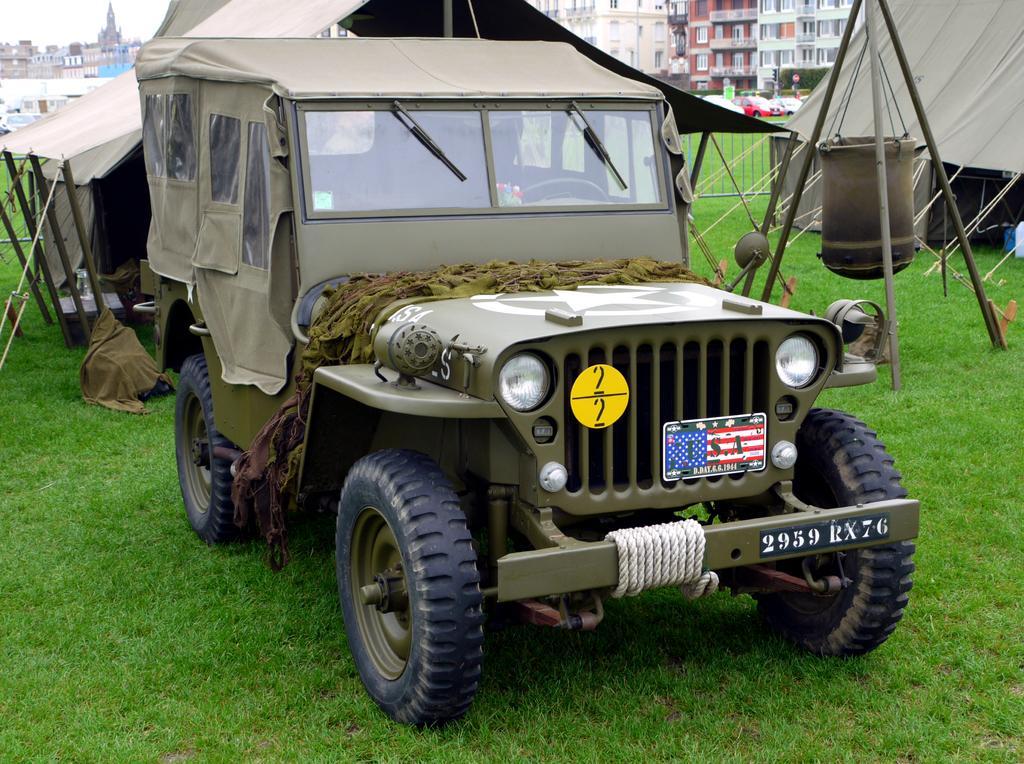Can you describe this image briefly? In this picture we can see a jeep here, at the bottom there is grass, we can see two tents here, in the background there are some buildings, we can see sky at the left top of the picture, there is a cloth here. 